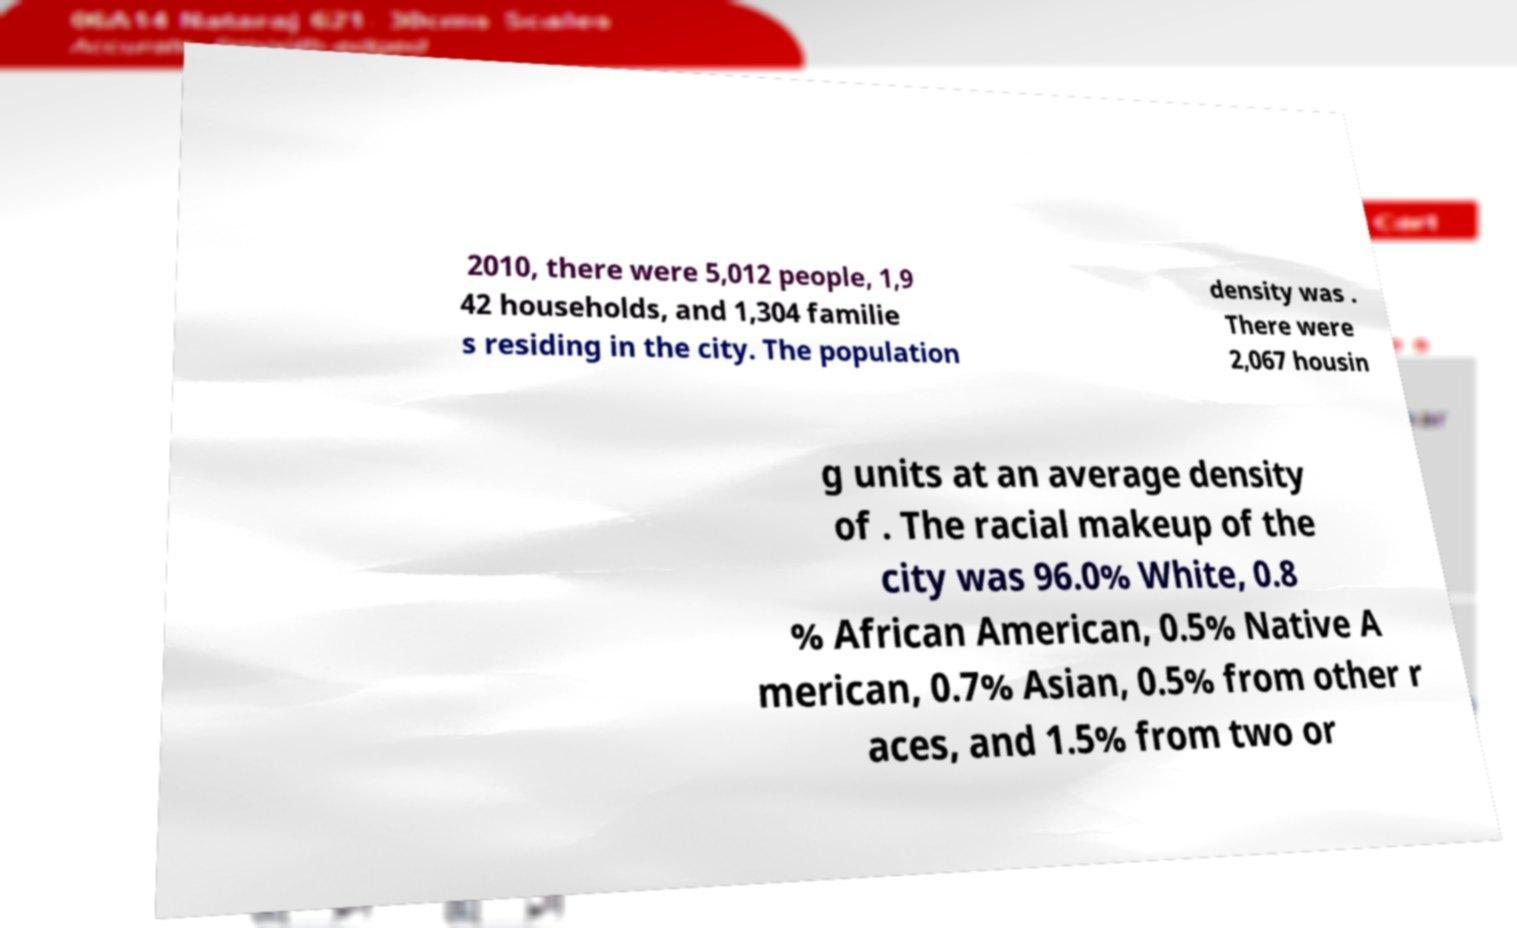Please read and relay the text visible in this image. What does it say? 2010, there were 5,012 people, 1,9 42 households, and 1,304 familie s residing in the city. The population density was . There were 2,067 housin g units at an average density of . The racial makeup of the city was 96.0% White, 0.8 % African American, 0.5% Native A merican, 0.7% Asian, 0.5% from other r aces, and 1.5% from two or 